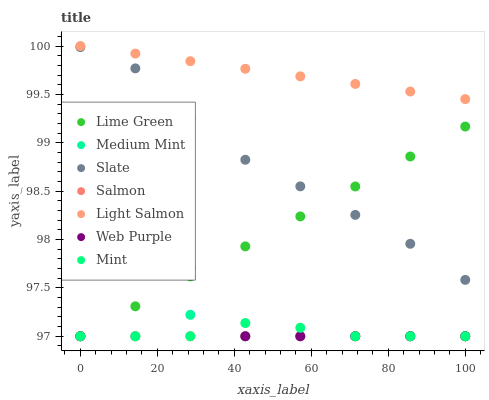Does Salmon have the minimum area under the curve?
Answer yes or no. Yes. Does Light Salmon have the maximum area under the curve?
Answer yes or no. Yes. Does Mint have the minimum area under the curve?
Answer yes or no. No. Does Mint have the maximum area under the curve?
Answer yes or no. No. Is Salmon the smoothest?
Answer yes or no. Yes. Is Web Purple the roughest?
Answer yes or no. Yes. Is Light Salmon the smoothest?
Answer yes or no. No. Is Light Salmon the roughest?
Answer yes or no. No. Does Medium Mint have the lowest value?
Answer yes or no. Yes. Does Light Salmon have the lowest value?
Answer yes or no. No. Does Light Salmon have the highest value?
Answer yes or no. Yes. Does Mint have the highest value?
Answer yes or no. No. Is Mint less than Slate?
Answer yes or no. Yes. Is Slate greater than Mint?
Answer yes or no. Yes. Does Lime Green intersect Mint?
Answer yes or no. Yes. Is Lime Green less than Mint?
Answer yes or no. No. Is Lime Green greater than Mint?
Answer yes or no. No. Does Mint intersect Slate?
Answer yes or no. No. 